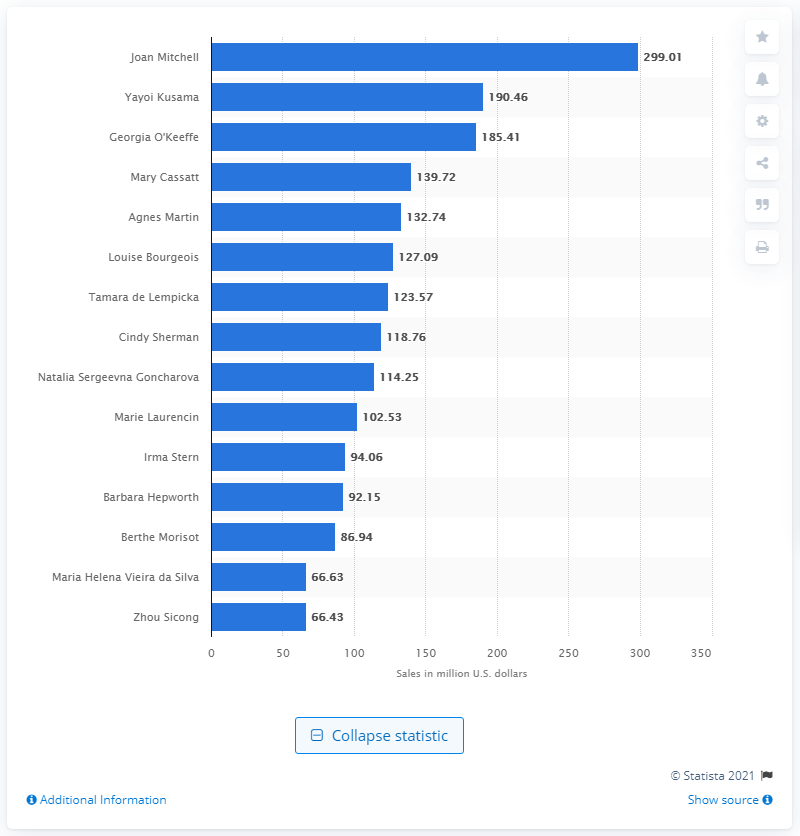Give some essential details in this illustration. The value of Joan Mitchell's art as of November 30, 2014, was $299.01. 